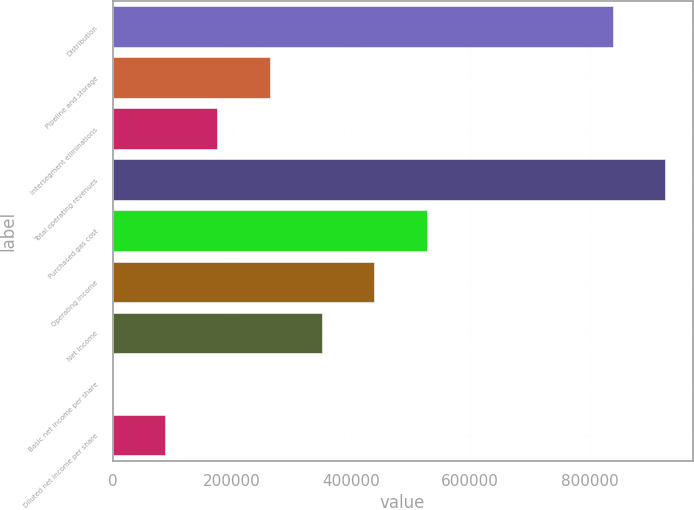Convert chart to OTSL. <chart><loc_0><loc_0><loc_500><loc_500><bar_chart><fcel>Distribution<fcel>Pipeline and storage<fcel>Intersegment eliminations<fcel>Total operating revenues<fcel>Purchased gas cost<fcel>Operating income<fcel>Net Income<fcel>Basic net income per share<fcel>Diluted net income per share<nl><fcel>838835<fcel>263336<fcel>175558<fcel>926613<fcel>526670<fcel>438892<fcel>351114<fcel>1.38<fcel>87779.4<nl></chart> 